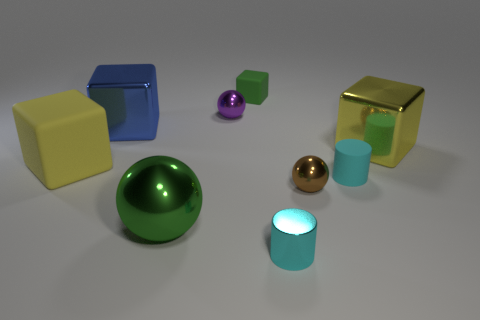Subtract 1 blocks. How many blocks are left? 3 Add 1 big purple shiny cylinders. How many objects exist? 10 Subtract all cylinders. How many objects are left? 7 Add 8 tiny purple objects. How many tiny purple objects are left? 9 Add 2 small brown metal balls. How many small brown metal balls exist? 3 Subtract 0 brown blocks. How many objects are left? 9 Subtract all tiny brown metal balls. Subtract all big balls. How many objects are left? 7 